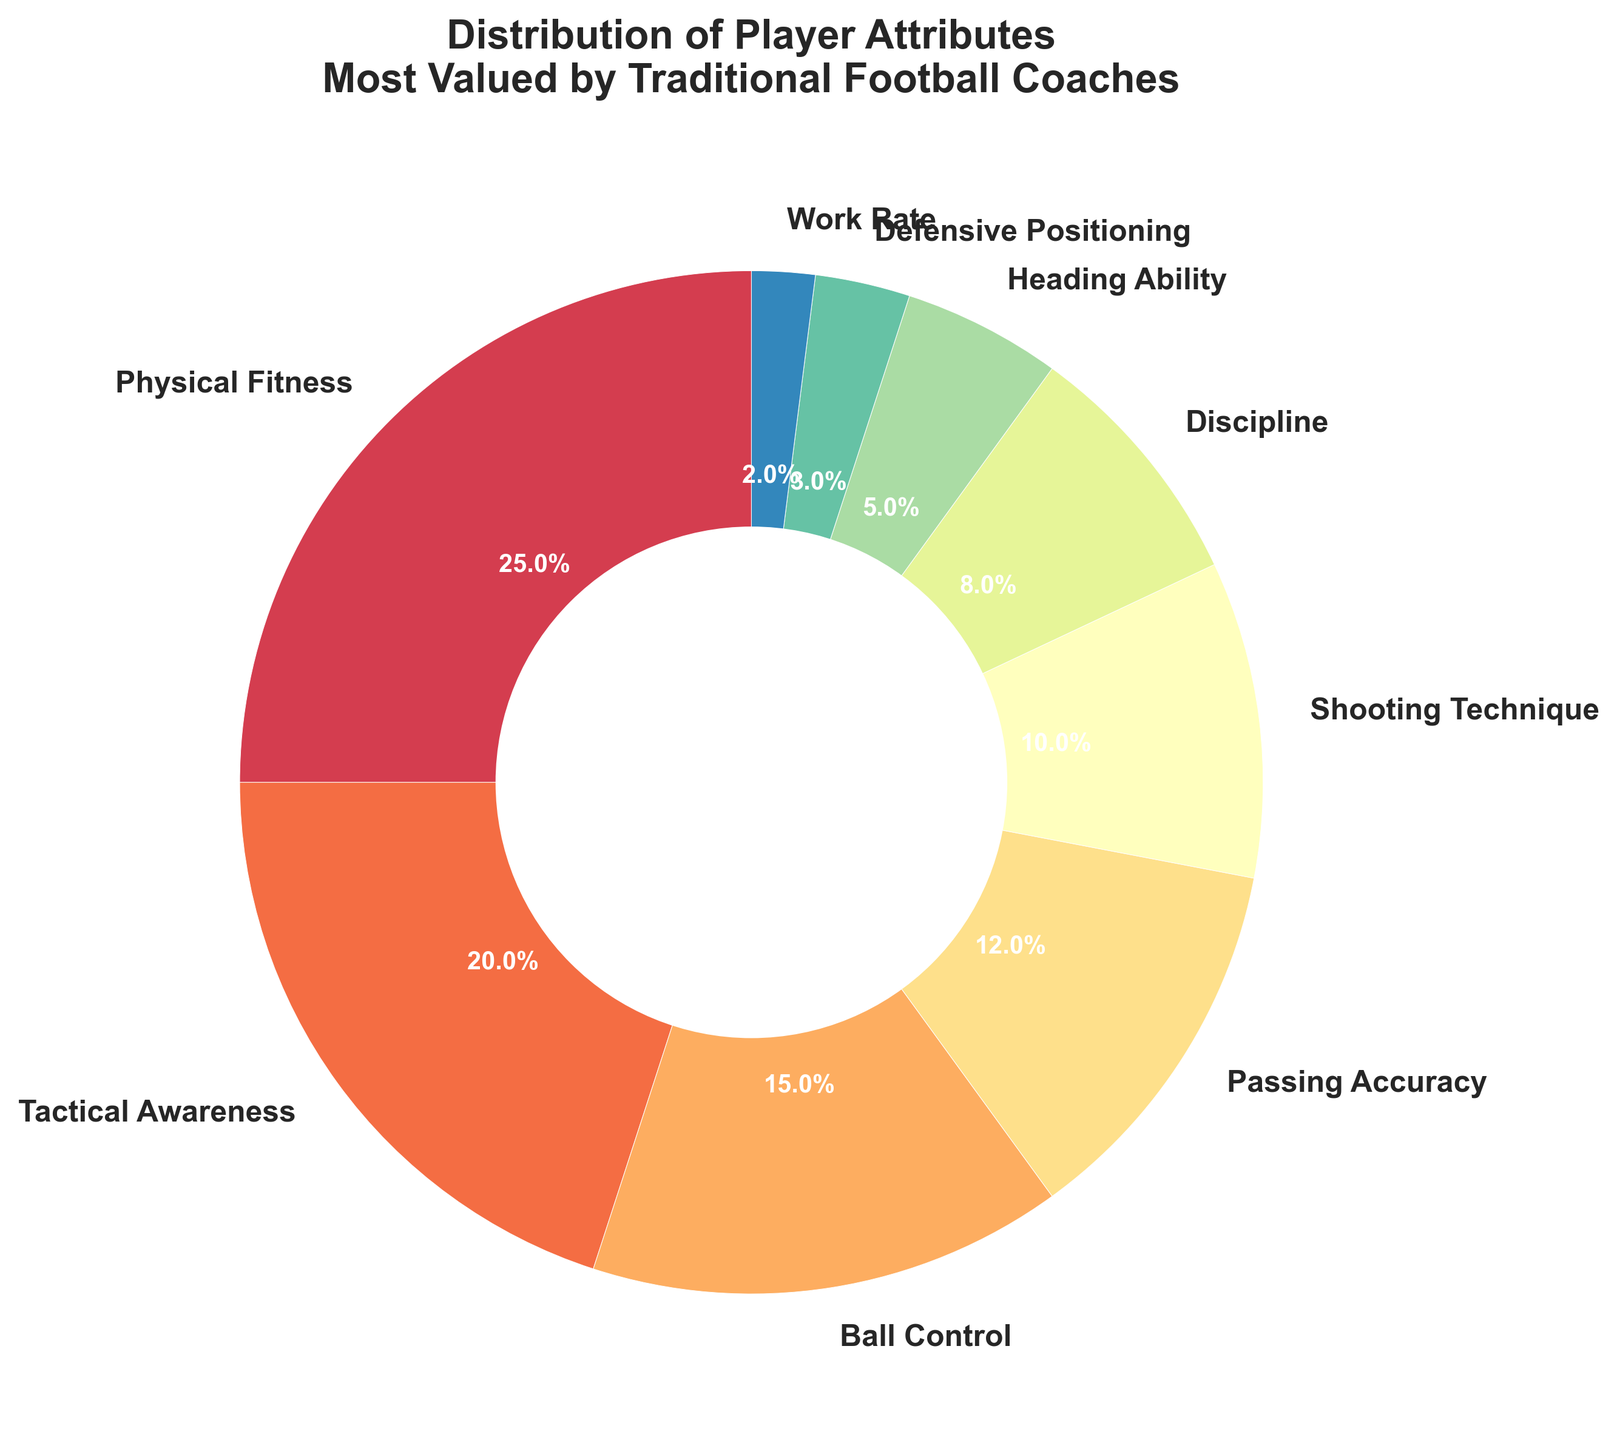Which attribute has the highest percentage? By looking at the pie chart, the segment labeled "Physical Fitness" has the largest size, indicating it has the highest percentage.
Answer: Physical Fitness How much is the combined percentage of Ball Control and Passing Accuracy? The percentage for Ball Control is 15%, and for Passing Accuracy, it is 12%. By adding these two values (15 + 12), the combined percentage is 27%.
Answer: 27% Which attributes have a percentage less than 10%? By identifying the segments of the pie chart labeled with percentages less than 10%, we find Shooting Technique (10% is not less), Discipline (8%), Heading Ability (5%), Defensive Positioning (3%), and Work Rate (2%).
Answer: Discipline, Heading Ability, Defensive Positioning, Work Rate What is the difference in percentage between Tactical Awareness and Discipline? By noting the percentages for Tactical Awareness (20%) and Discipline (8%) and calculating the difference (20 - 8), it is 12%.
Answer: 12% Compare the importance of Physical Fitness and Ball Control. Which one is more valued? Looking at the given pie chart, Physical Fitness has a larger segment (25%) than Ball Control (15%), indicating it is more valued.
Answer: Physical Fitness Which attribute is valued the least and what is its percentage? By identifying the smallest segment in the pie chart, labeled "Work Rate," we see it has the lowest percentage, which is 2%.
Answer: Work Rate, 2% Is the segment for Shooting Technique larger or smaller than Passing Accuracy? Upon inspection, Shooting Technique has a 10% segment, while Passing Accuracy has 12%. Therefore, Shooting Technique’s segment is smaller.
Answer: Smaller What is the sum of the percentages of Defensive Positioning, Heading Ability, and Work Rate? Adding the percentages for Defensive Positioning (3%), Heading Ability (5%), and Work Rate (2%) results in 3 + 5 + 2 = 10%.
Answer: 10% How does the percentage for Discipline compare to Heading Ability and Defensive Positioning combined? The percentage for Discipline is 8%. Combining Heading Ability (5%) and Defensive Positioning (3%) results in 5 + 3 = 8%, equal to the percentage for Discipline.
Answer: Equal What is the combined percentage of attributes with values greater than or equal to 15%? The attributes with percentages greater than or equal to 15% are Physical Fitness (25%), Tactical Awareness (20%), and Ball Control (15%). Adding these values (25 + 20 + 15) results in 60%.
Answer: 60% 